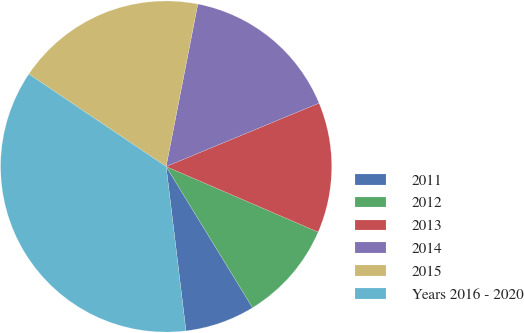<chart> <loc_0><loc_0><loc_500><loc_500><pie_chart><fcel>2011<fcel>2012<fcel>2013<fcel>2014<fcel>2015<fcel>Years 2016 - 2020<nl><fcel>6.83%<fcel>9.78%<fcel>12.73%<fcel>15.68%<fcel>18.63%<fcel>36.34%<nl></chart> 